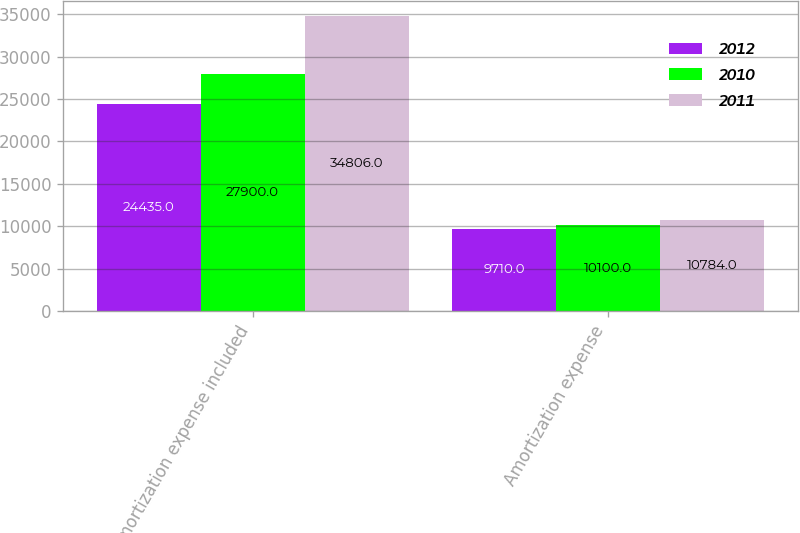Convert chart. <chart><loc_0><loc_0><loc_500><loc_500><stacked_bar_chart><ecel><fcel>Amortization expense included<fcel>Amortization expense<nl><fcel>2012<fcel>24435<fcel>9710<nl><fcel>2010<fcel>27900<fcel>10100<nl><fcel>2011<fcel>34806<fcel>10784<nl></chart> 